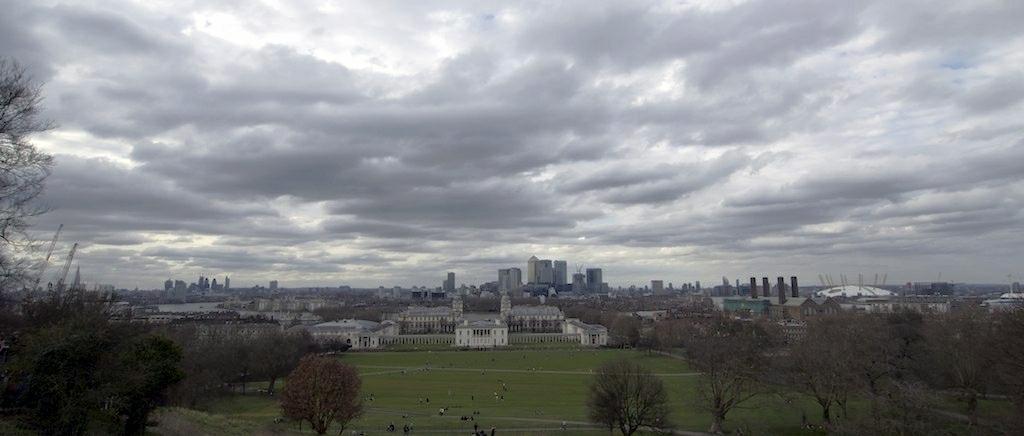Could you give a brief overview of what you see in this image? Sky is cloudy. Here we can see people, buildings, grass and trees.   